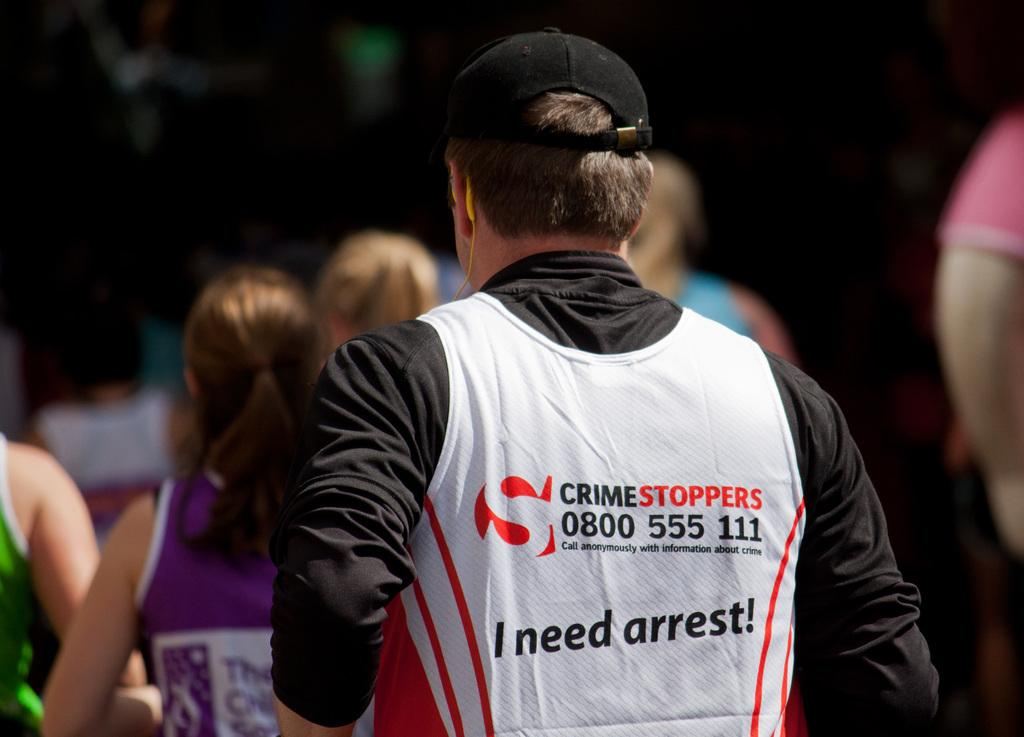How many people are in the image? There are multiple persons in the image. Can you describe the person in the front? The person in the front is wearing a black shirt and a cap. How many toes can be seen on the person in the front? There is no information about the person's toes in the image, so it cannot be determined. 